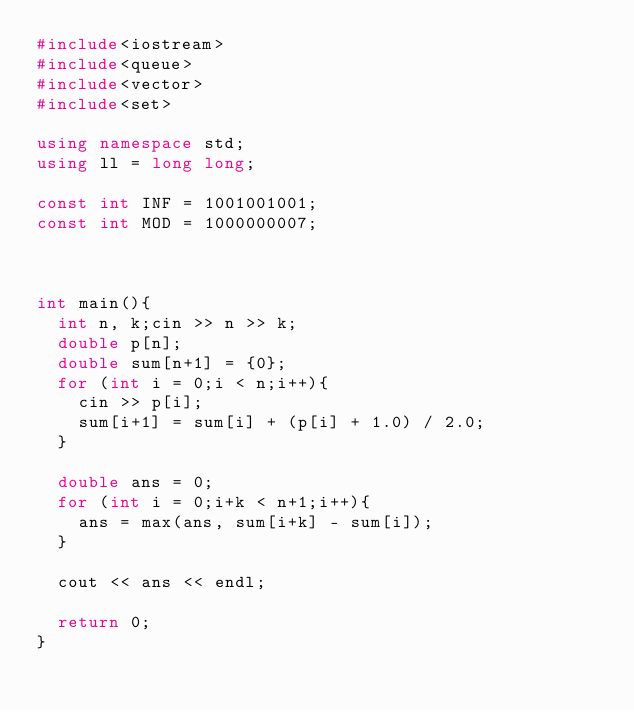<code> <loc_0><loc_0><loc_500><loc_500><_C++_>#include<iostream>
#include<queue>
#include<vector>
#include<set>

using namespace std;
using ll = long long;

const int INF = 1001001001;
const int MOD = 1000000007;



int main(){
	int n, k;cin >> n >> k;
	double p[n];
	double sum[n+1] = {0};
	for (int i = 0;i < n;i++){
		cin >> p[i];
		sum[i+1] = sum[i] + (p[i] + 1.0) / 2.0;
	}

	double ans = 0;
	for (int i = 0;i+k < n+1;i++){
		ans = max(ans, sum[i+k] - sum[i]);
	}

	cout << ans << endl;
	
	return 0;
}
</code> 